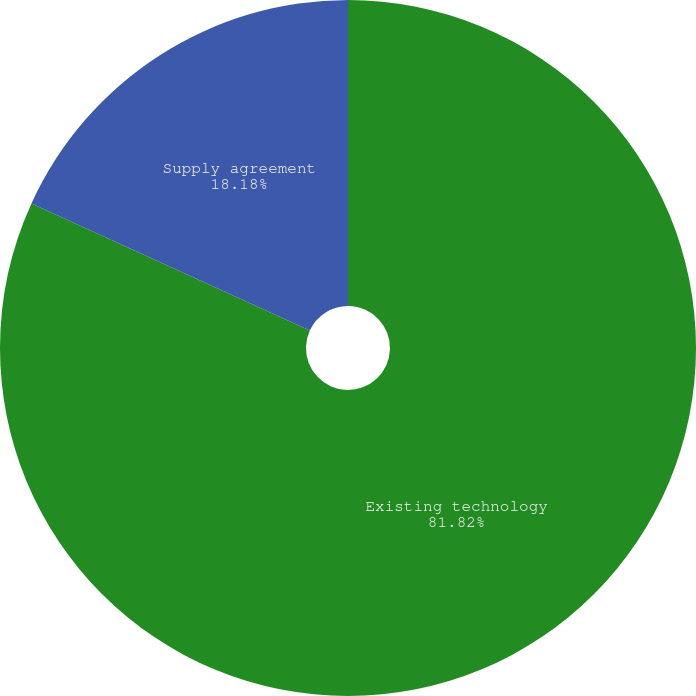Convert chart. <chart><loc_0><loc_0><loc_500><loc_500><pie_chart><fcel>Existing technology<fcel>Supply agreement<nl><fcel>81.82%<fcel>18.18%<nl></chart> 